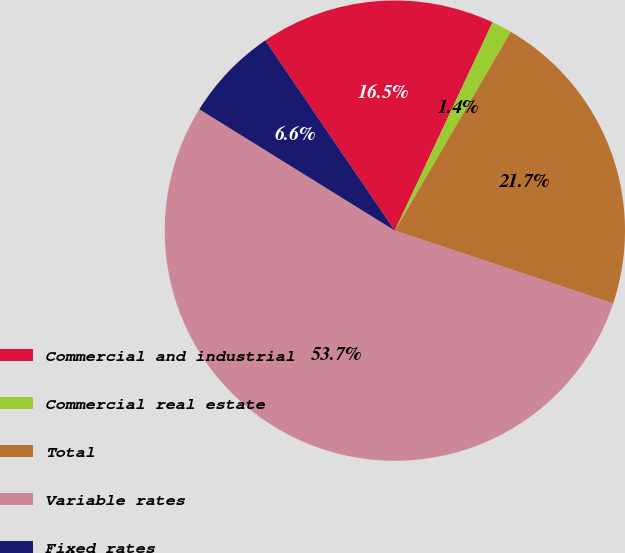Convert chart. <chart><loc_0><loc_0><loc_500><loc_500><pie_chart><fcel>Commercial and industrial<fcel>Commercial real estate<fcel>Total<fcel>Variable rates<fcel>Fixed rates<nl><fcel>16.5%<fcel>1.42%<fcel>21.73%<fcel>53.71%<fcel>6.64%<nl></chart> 